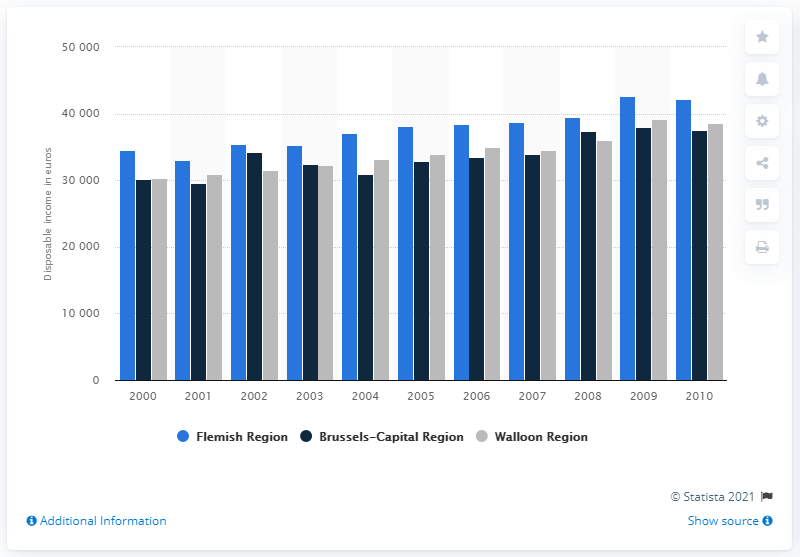Indicate a few pertinent items in this graphic. In 2010, the median disposable income for a household in the Walloon Region was 39,205 euros. In 2010, the median disposable income for a household living in the Flemish Region was 42,182 euros. 